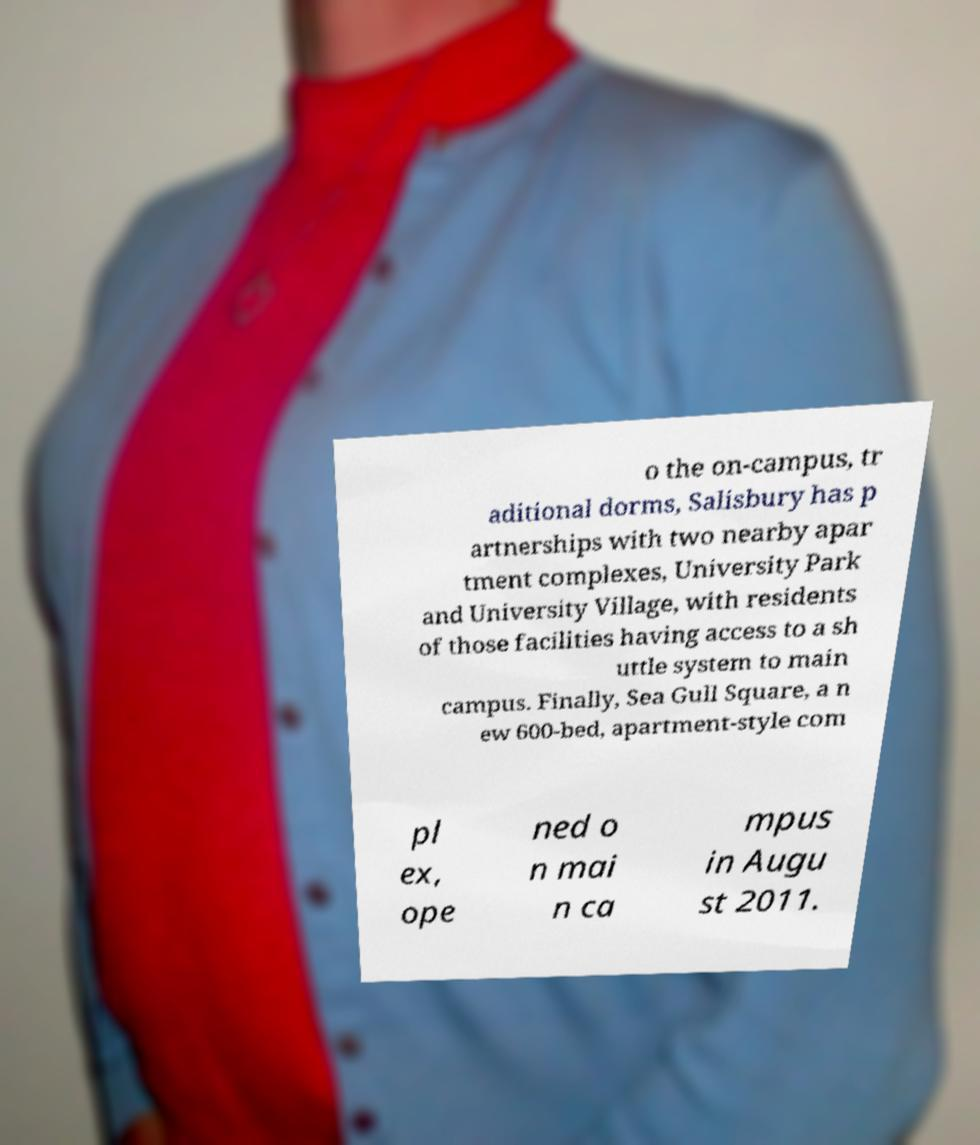For documentation purposes, I need the text within this image transcribed. Could you provide that? o the on-campus, tr aditional dorms, Salisbury has p artnerships with two nearby apar tment complexes, University Park and University Village, with residents of those facilities having access to a sh uttle system to main campus. Finally, Sea Gull Square, a n ew 600-bed, apartment-style com pl ex, ope ned o n mai n ca mpus in Augu st 2011. 